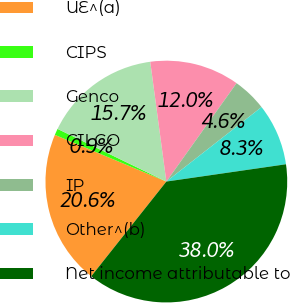Convert chart. <chart><loc_0><loc_0><loc_500><loc_500><pie_chart><fcel>UE^(a)<fcel>CIPS<fcel>Genco<fcel>CILCO<fcel>IP<fcel>Other^(b)<fcel>Net income attributable to<nl><fcel>20.64%<fcel>0.86%<fcel>15.7%<fcel>11.99%<fcel>4.57%<fcel>8.28%<fcel>37.96%<nl></chart> 